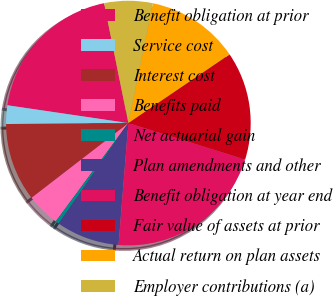Convert chart to OTSL. <chart><loc_0><loc_0><loc_500><loc_500><pie_chart><fcel>Benefit obligation at prior<fcel>Service cost<fcel>Interest cost<fcel>Benefits paid<fcel>Net actuarial gain<fcel>Plan amendments and other<fcel>Benefit obligation at year end<fcel>Fair value of assets at prior<fcel>Actual return on plan assets<fcel>Employer contributions (a)<nl><fcel>19.49%<fcel>2.45%<fcel>10.33%<fcel>4.42%<fcel>0.48%<fcel>8.36%<fcel>21.46%<fcel>14.3%<fcel>12.3%<fcel>6.39%<nl></chart> 